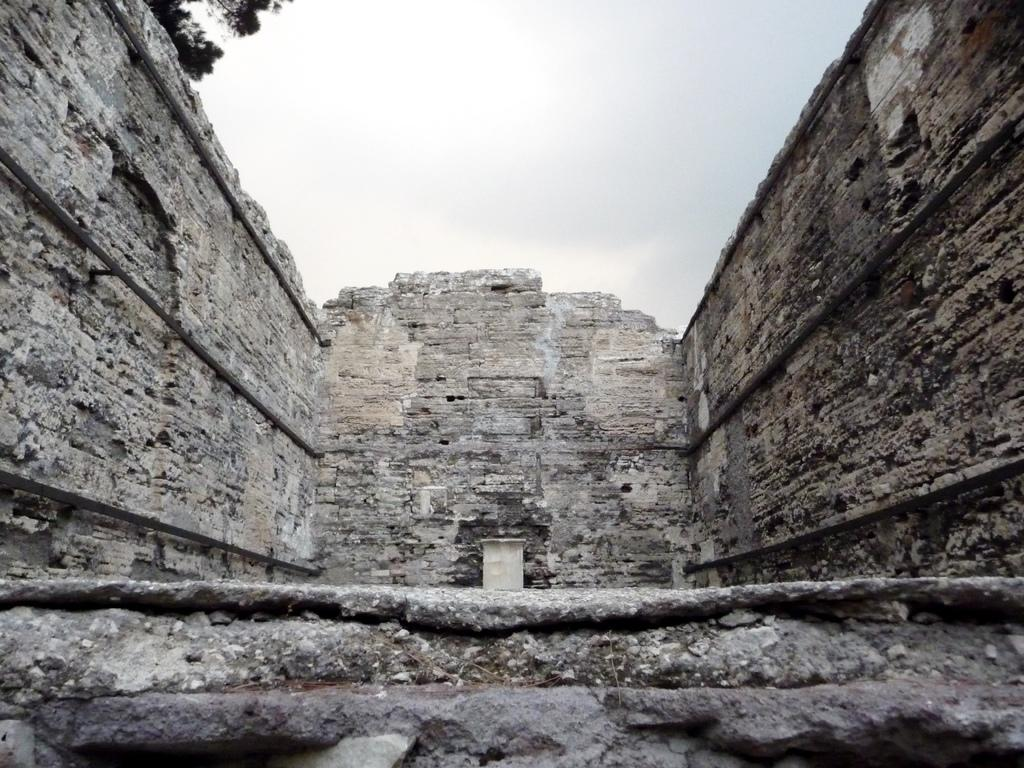What type of structure is depicted in the image? The image shows the walls of a building. What can be seen above the building in the image? The sky is visible at the top of the image. Is there any vegetation visible in the image? It is less certain due to the ambiguity in the transcript, but there might be a tree at the top side of the image. What type of popcorn is being served in the image? There is no popcorn present in the image; it features the walls of a building and the sky. Can you tell me how many fowl are perched on the tree in the image? There is no tree or fowl present in the image; it only shows the walls of a building and the sky. 